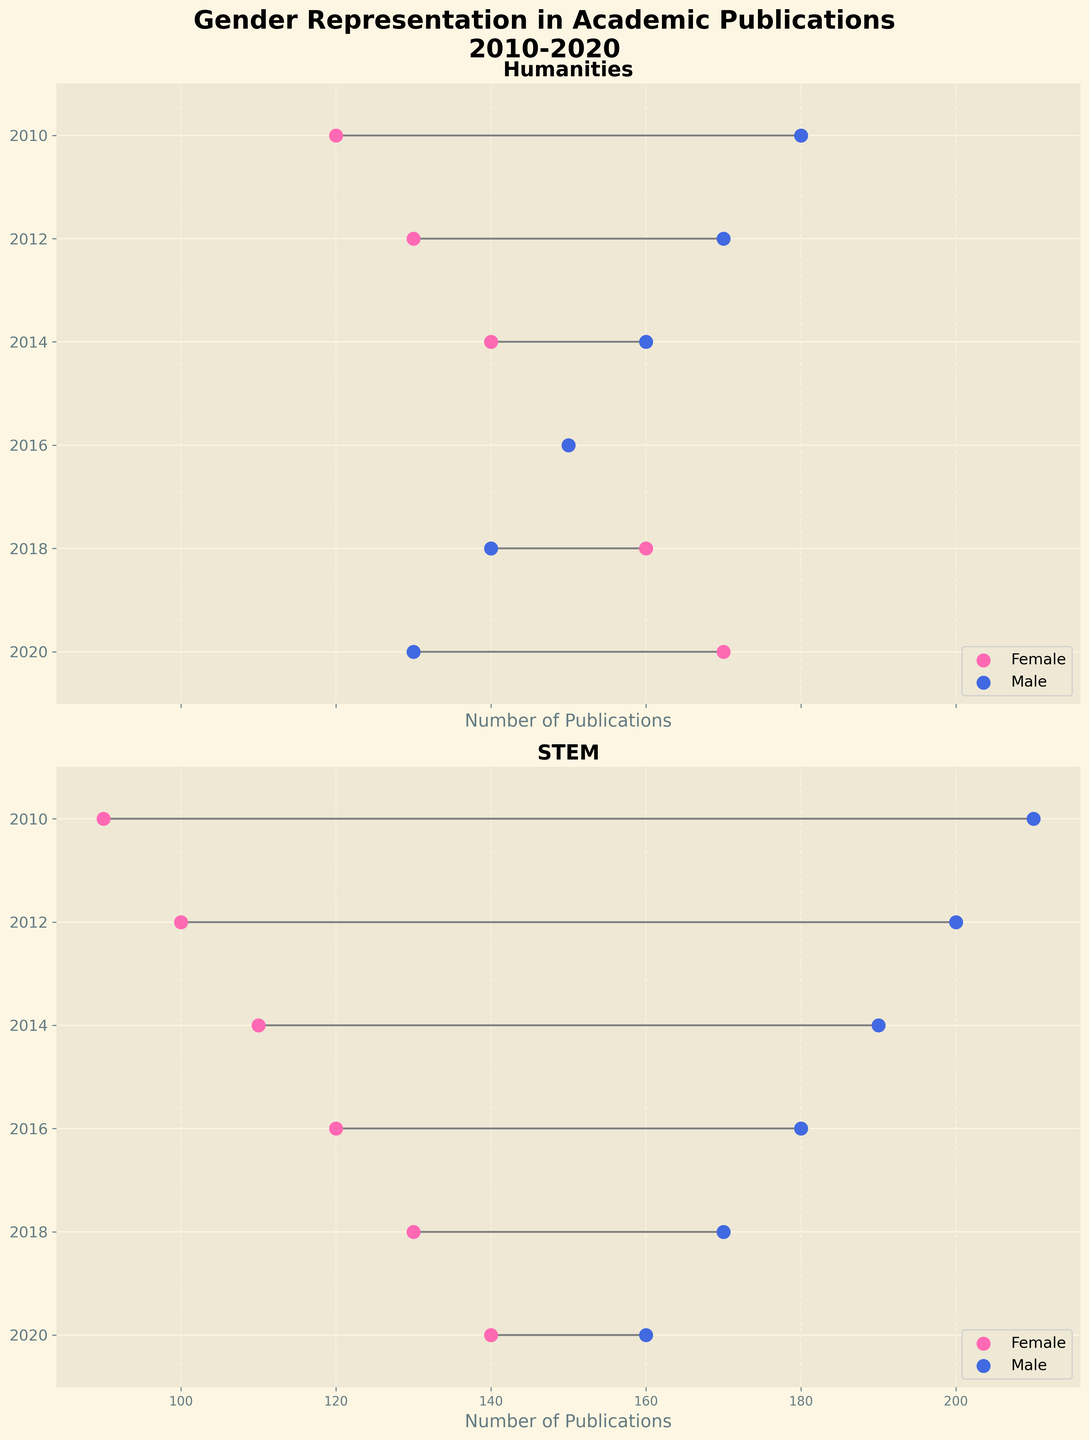What does the title of the figure indicate? The title of the figure is "Gender Representation in Academic Publications\n2010-2020". It indicates that the figure shows data on the number of publications authored by males and females in academic disciplines from 2010 to 2020.
Answer: Gender Representation in Academic Publications 2010-2020 Name the two academic disciplines compared in the figure. Look at the titles above the subplots in the figure. Each subplot title represents a different academic discipline being compared.
Answer: Humanities and STEM In which year did the number of publications by females in STEM surpass 120? Refer to the vertical axis for years and then look at the female plots/points in the STEM field. Identify the first year where female publications exceed 120.
Answer: 2018 Which gender had the most publications in Humanities in 2014? For the year 2014, compare the female and male data points in the Humanities section. The marker representing the highest number of publications indicates the most publications.
Answer: Female Compare the gap between male and female publications in STEM for the year 2020. Locate the 2020 data points in the STEM section. Check the difference in publication counts for males and females. Subtract the female count from the male count.
Answer: 20 Which year shows the smallest gender gap in publications for Humanities? Find the year where the difference between male and female publications is minimal by visually comparing the horizontal distances between their data points in Humanities.
Answer: 2016 What's the trend of female publications in STEM from 2010 to 2020? Examine the positions of the female data points in STEM across the years. Identify whether the numbers are increasing, decreasing, or fluctuating.
Answer: Increasing Which discipline and year show the largest male publication count? Identify the highest data point for males across both disciplines and all years.
Answer: STEM, 2010 How many years saw males having fewer publications than females in Humanities? Examine each year in the Humanities section and count the years where the male data point is lower than the female data point.
Answer: 3 (2018, 2020, 2016) Is the trend of gender disparity narrowing or widening in STEM from 2010 to 2020? Observe the gap between male and female publication counts in STEM over the years. If the gap is getting smaller, it is narrowing; if it is getting larger, it is widening.
Answer: Narrowing 